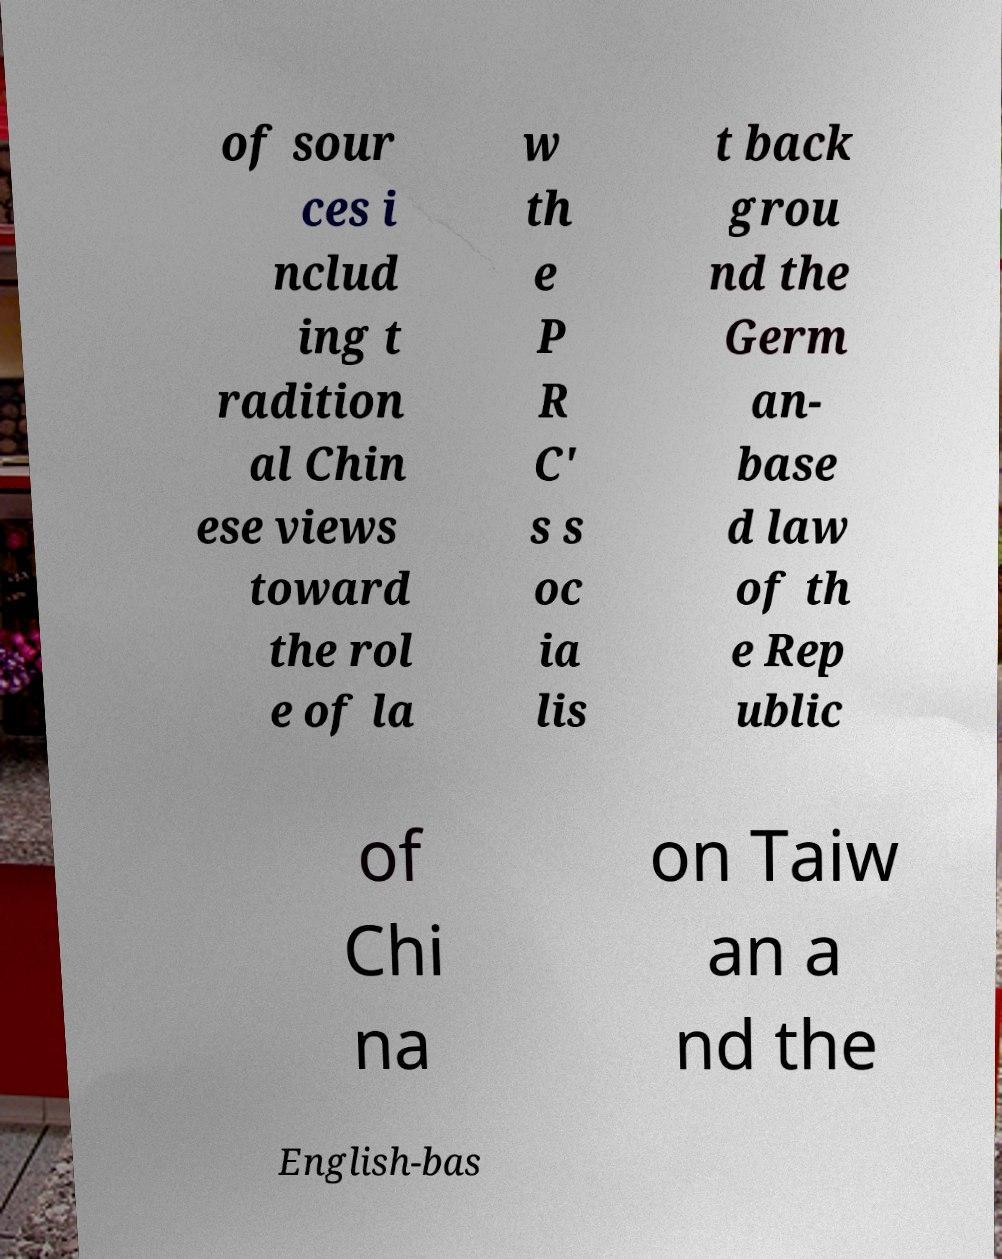There's text embedded in this image that I need extracted. Can you transcribe it verbatim? of sour ces i nclud ing t radition al Chin ese views toward the rol e of la w th e P R C' s s oc ia lis t back grou nd the Germ an- base d law of th e Rep ublic of Chi na on Taiw an a nd the English-bas 